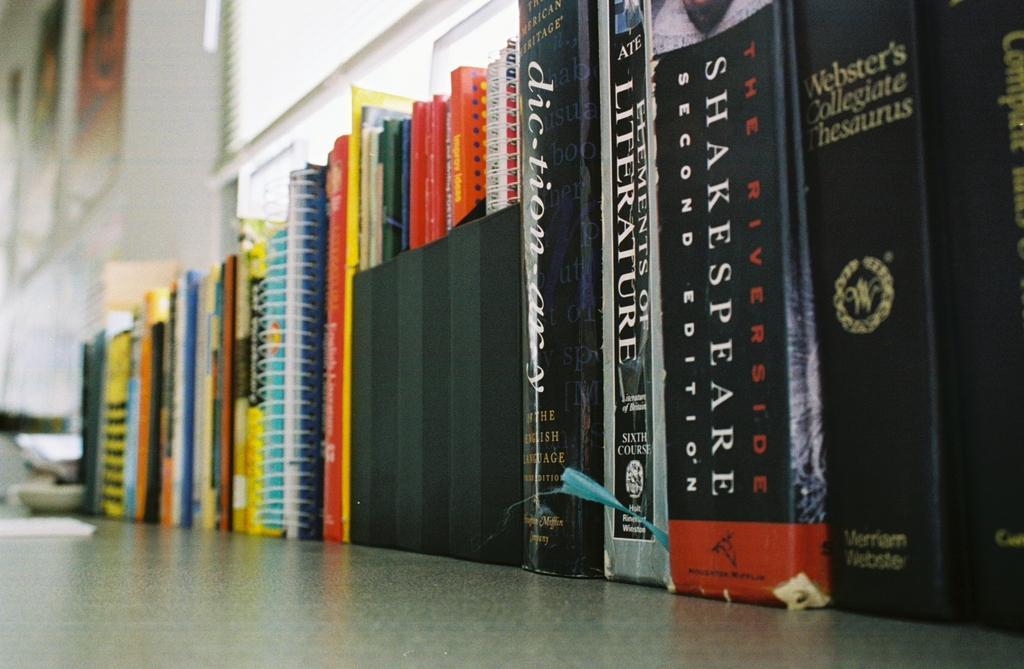Can you describe this image briefly? In this image I can see number of books and on the right side of this image I can see something is written on these books. I can also see this image is little bit blurry in the background. 